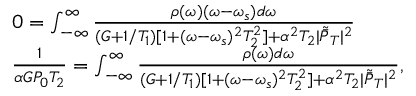<formula> <loc_0><loc_0><loc_500><loc_500>\begin{array} { r l } & { 0 = \int _ { - \infty } ^ { \infty } \frac { \rho ( \omega ) ( \omega - \omega _ { s } ) d \omega } { ( G + { 1 } / { T _ { 1 } } ) [ 1 + ( \omega - \omega _ { s } ) ^ { 2 } T _ { 2 } ^ { 2 } ] + \alpha ^ { 2 } T _ { 2 } | \tilde { \bar { P } } _ { T } | ^ { 2 } } } \\ & { \frac { 1 } \alpha G P _ { 0 } T _ { 2 } } = \int _ { - \infty } ^ { \infty } \frac { \rho ( \omega ) d \omega } { ( G + 1 / T _ { 1 } ) [ 1 + ( \omega - \omega _ { s } ) ^ { 2 } T _ { 2 } ^ { 2 } ] + \alpha ^ { 2 } T _ { 2 } | \tilde { \bar { P } } _ { T } | ^ { 2 } } , } \end{array}</formula> 